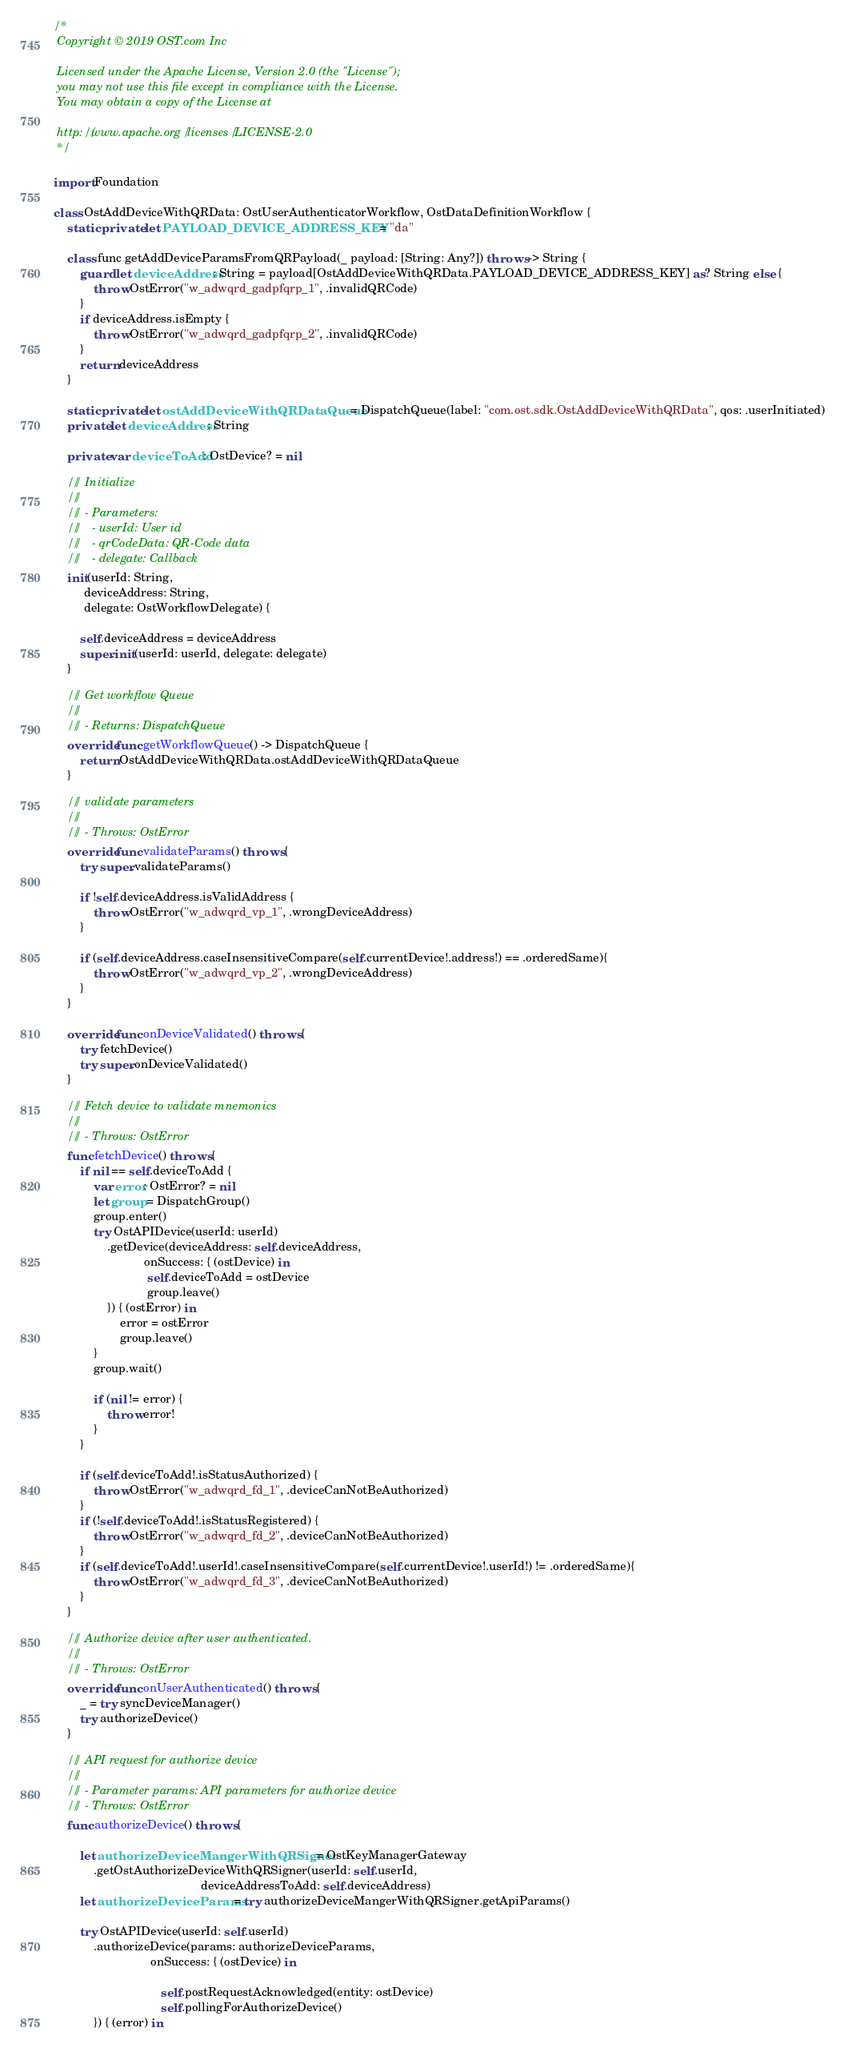<code> <loc_0><loc_0><loc_500><loc_500><_Swift_>/*
 Copyright © 2019 OST.com Inc
 
 Licensed under the Apache License, Version 2.0 (the "License");
 you may not use this file except in compliance with the License.
 You may obtain a copy of the License at
 
 http://www.apache.org/licenses/LICENSE-2.0
 */

import Foundation

class OstAddDeviceWithQRData: OstUserAuthenticatorWorkflow, OstDataDefinitionWorkflow {
    static private let PAYLOAD_DEVICE_ADDRESS_KEY = "da"
    
    class func getAddDeviceParamsFromQRPayload(_ payload: [String: Any?]) throws -> String {
        guard let deviceAddress: String = payload[OstAddDeviceWithQRData.PAYLOAD_DEVICE_ADDRESS_KEY] as? String else {
            throw OstError("w_adwqrd_gadpfqrp_1", .invalidQRCode)
        }
        if deviceAddress.isEmpty {
            throw OstError("w_adwqrd_gadpfqrp_2", .invalidQRCode)
        }
        return deviceAddress
    }
    
    static private let ostAddDeviceWithQRDataQueue = DispatchQueue(label: "com.ost.sdk.OstAddDeviceWithQRData", qos: .userInitiated)
    private let deviceAddress: String
    
    private var deviceToAdd: OstDevice? = nil
    
    /// Initialize
    ///
    /// - Parameters:
    ///   - userId: User id
    ///   - qrCodeData: QR-Code data
    ///   - delegate: Callback
    init(userId: String,
         deviceAddress: String,
         delegate: OstWorkflowDelegate) {
        
        self.deviceAddress = deviceAddress
        super.init(userId: userId, delegate: delegate)
    }
    
    /// Get workflow Queue
    ///
    /// - Returns: DispatchQueue
    override func getWorkflowQueue() -> DispatchQueue {
        return OstAddDeviceWithQRData.ostAddDeviceWithQRDataQueue
    }
    
    /// validate parameters
    ///
    /// - Throws: OstError
    override func validateParams() throws {
        try super.validateParams()
        
        if !self.deviceAddress.isValidAddress {
            throw OstError("w_adwqrd_vp_1", .wrongDeviceAddress)
        }
        
        if (self.deviceAddress.caseInsensitiveCompare(self.currentDevice!.address!) == .orderedSame){
            throw OstError("w_adwqrd_vp_2", .wrongDeviceAddress)
        }
    }
    
    override func onDeviceValidated() throws {
        try fetchDevice()
        try super.onDeviceValidated()
    }
    
    /// Fetch device to validate mnemonics
    ///
    /// - Throws: OstError
    func fetchDevice() throws {
        if nil == self.deviceToAdd {
            var error: OstError? = nil
            let group = DispatchGroup()
            group.enter()
            try OstAPIDevice(userId: userId)
                .getDevice(deviceAddress: self.deviceAddress,
                           onSuccess: { (ostDevice) in
                            self.deviceToAdd = ostDevice
                            group.leave()
                }) { (ostError) in
                    error = ostError
                    group.leave()
            }
            group.wait()
            
            if (nil != error) {
                throw error!
            }
        }
        
        if (self.deviceToAdd!.isStatusAuthorized) {
            throw OstError("w_adwqrd_fd_1", .deviceCanNotBeAuthorized)
        }
        if (!self.deviceToAdd!.isStatusRegistered) {
            throw OstError("w_adwqrd_fd_2", .deviceCanNotBeAuthorized)
        }
        if (self.deviceToAdd!.userId!.caseInsensitiveCompare(self.currentDevice!.userId!) != .orderedSame){
            throw OstError("w_adwqrd_fd_3", .deviceCanNotBeAuthorized)
        }
    }
    
    /// Authorize device after user authenticated.
    ///
    /// - Throws: OstError
    override func onUserAuthenticated() throws {
        _ = try syncDeviceManager()
        try authorizeDevice()
    }
    
    /// API request for authorize device
    ///
    /// - Parameter params: API parameters for authorize device
    /// - Throws: OstError
    func authorizeDevice() throws {
        
        let authorizeDeviceMangerWithQRSigner = OstKeyManagerGateway
            .getOstAuthorizeDeviceWithQRSigner(userId: self.userId,
                                            deviceAddressToAdd: self.deviceAddress)
        let authorizeDeviceParams = try authorizeDeviceMangerWithQRSigner.getApiParams()
        
        try OstAPIDevice(userId: self.userId)
            .authorizeDevice(params: authorizeDeviceParams,
                             onSuccess: { (ostDevice) in
                                
                                self.postRequestAcknowledged(entity: ostDevice)
                                self.pollingForAuthorizeDevice()
            }) { (error) in</code> 